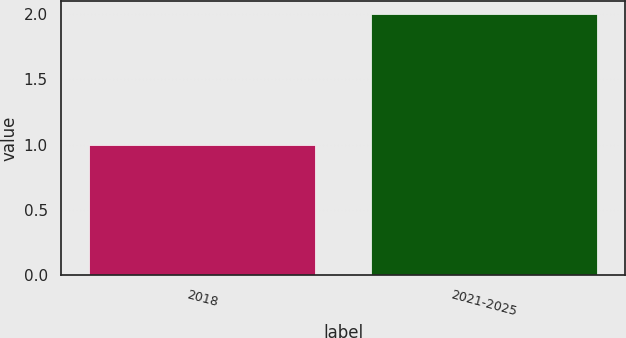Convert chart to OTSL. <chart><loc_0><loc_0><loc_500><loc_500><bar_chart><fcel>2018<fcel>2021-2025<nl><fcel>1<fcel>2<nl></chart> 